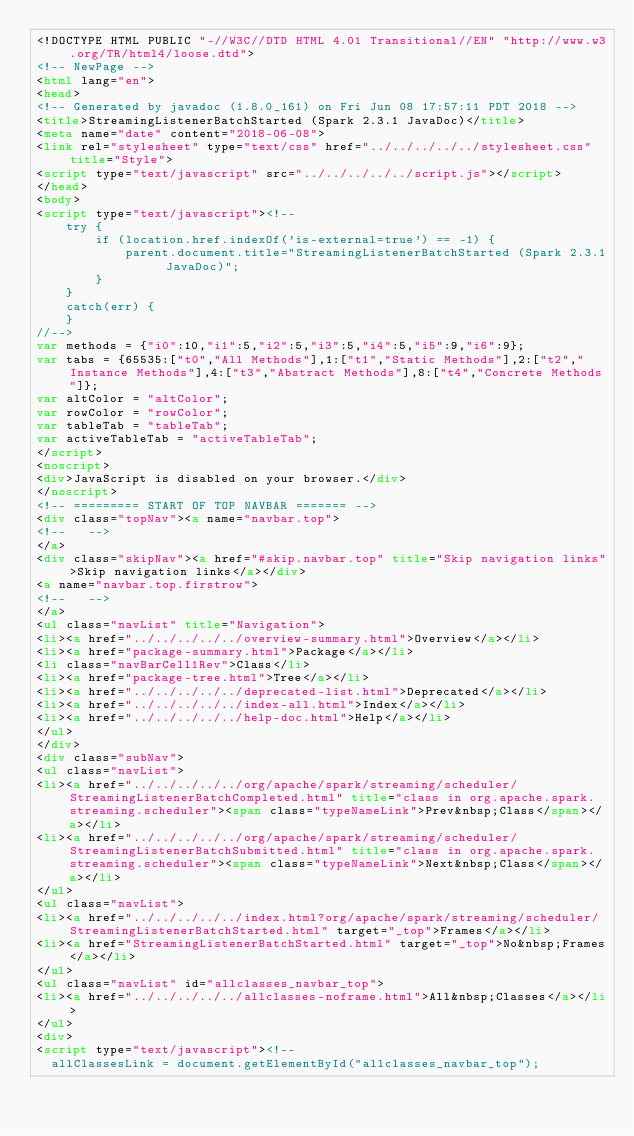Convert code to text. <code><loc_0><loc_0><loc_500><loc_500><_HTML_><!DOCTYPE HTML PUBLIC "-//W3C//DTD HTML 4.01 Transitional//EN" "http://www.w3.org/TR/html4/loose.dtd">
<!-- NewPage -->
<html lang="en">
<head>
<!-- Generated by javadoc (1.8.0_161) on Fri Jun 08 17:57:11 PDT 2018 -->
<title>StreamingListenerBatchStarted (Spark 2.3.1 JavaDoc)</title>
<meta name="date" content="2018-06-08">
<link rel="stylesheet" type="text/css" href="../../../../../stylesheet.css" title="Style">
<script type="text/javascript" src="../../../../../script.js"></script>
</head>
<body>
<script type="text/javascript"><!--
    try {
        if (location.href.indexOf('is-external=true') == -1) {
            parent.document.title="StreamingListenerBatchStarted (Spark 2.3.1 JavaDoc)";
        }
    }
    catch(err) {
    }
//-->
var methods = {"i0":10,"i1":5,"i2":5,"i3":5,"i4":5,"i5":9,"i6":9};
var tabs = {65535:["t0","All Methods"],1:["t1","Static Methods"],2:["t2","Instance Methods"],4:["t3","Abstract Methods"],8:["t4","Concrete Methods"]};
var altColor = "altColor";
var rowColor = "rowColor";
var tableTab = "tableTab";
var activeTableTab = "activeTableTab";
</script>
<noscript>
<div>JavaScript is disabled on your browser.</div>
</noscript>
<!-- ========= START OF TOP NAVBAR ======= -->
<div class="topNav"><a name="navbar.top">
<!--   -->
</a>
<div class="skipNav"><a href="#skip.navbar.top" title="Skip navigation links">Skip navigation links</a></div>
<a name="navbar.top.firstrow">
<!--   -->
</a>
<ul class="navList" title="Navigation">
<li><a href="../../../../../overview-summary.html">Overview</a></li>
<li><a href="package-summary.html">Package</a></li>
<li class="navBarCell1Rev">Class</li>
<li><a href="package-tree.html">Tree</a></li>
<li><a href="../../../../../deprecated-list.html">Deprecated</a></li>
<li><a href="../../../../../index-all.html">Index</a></li>
<li><a href="../../../../../help-doc.html">Help</a></li>
</ul>
</div>
<div class="subNav">
<ul class="navList">
<li><a href="../../../../../org/apache/spark/streaming/scheduler/StreamingListenerBatchCompleted.html" title="class in org.apache.spark.streaming.scheduler"><span class="typeNameLink">Prev&nbsp;Class</span></a></li>
<li><a href="../../../../../org/apache/spark/streaming/scheduler/StreamingListenerBatchSubmitted.html" title="class in org.apache.spark.streaming.scheduler"><span class="typeNameLink">Next&nbsp;Class</span></a></li>
</ul>
<ul class="navList">
<li><a href="../../../../../index.html?org/apache/spark/streaming/scheduler/StreamingListenerBatchStarted.html" target="_top">Frames</a></li>
<li><a href="StreamingListenerBatchStarted.html" target="_top">No&nbsp;Frames</a></li>
</ul>
<ul class="navList" id="allclasses_navbar_top">
<li><a href="../../../../../allclasses-noframe.html">All&nbsp;Classes</a></li>
</ul>
<div>
<script type="text/javascript"><!--
  allClassesLink = document.getElementById("allclasses_navbar_top");</code> 